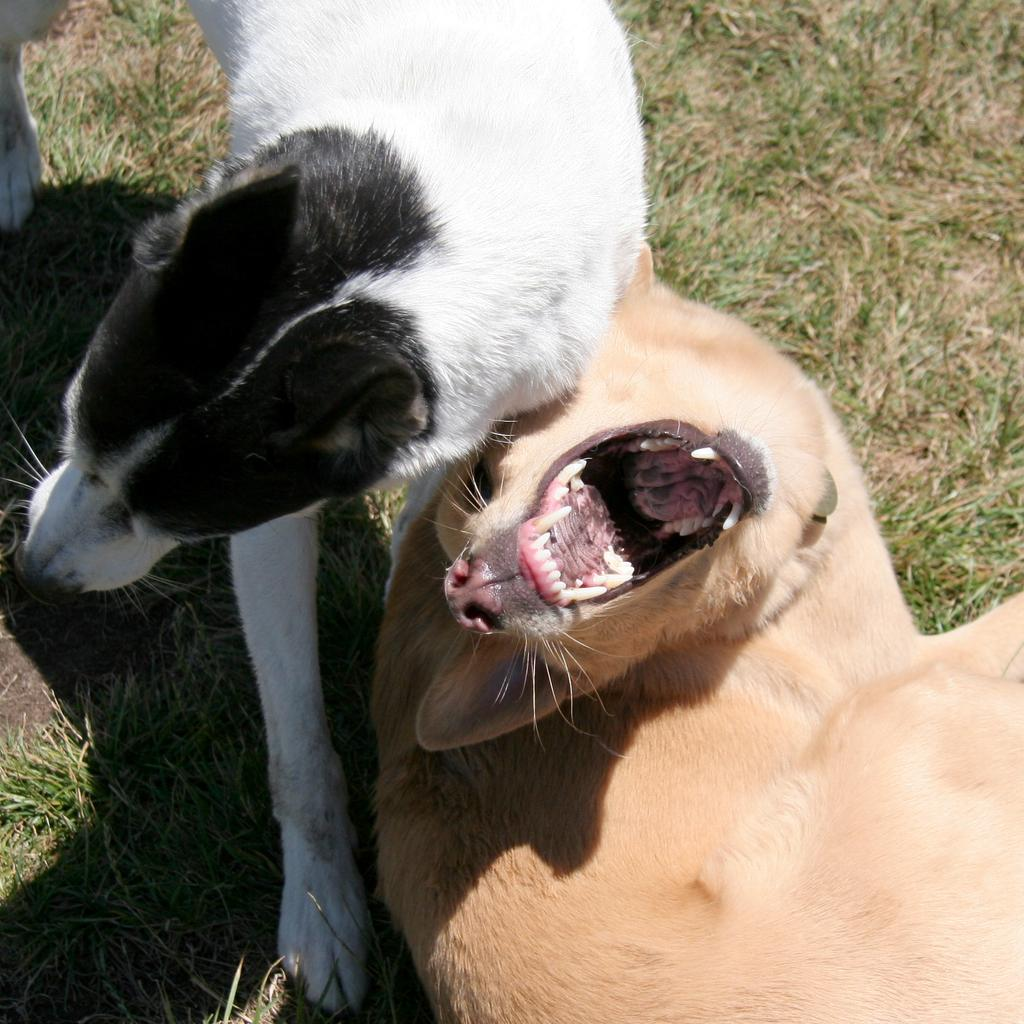What type of ground is visible in the image? There is grass ground in the image. What animals can be seen on the grass ground? There are two dogs on the grass ground. Can you describe the color of the first dog? One dog has a cream color. How would you describe the color pattern of the second dog? The other dog has a black and white color. What type of feather can be seen on the dogs in the image? There are no feathers present on the dogs in the image; they are dogs and have fur, not feathers. 